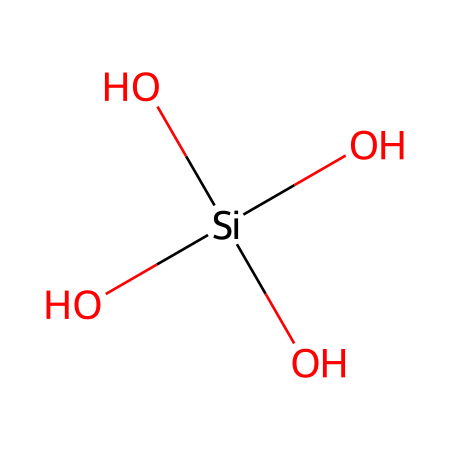How many oxygen atoms are in this chemical structure? The chemical structure contains four oxygen atoms, which can be identified from the visual representation where 'O' is shown four times.
Answer: four What is the central atom in this molecule? The central atom is silicon, which can be determined as 'Si' is present in the structure and is surrounded by oxygen atoms.
Answer: silicon How many hydroxyl groups are present in the structure? There are four hydroxyl groups (–OH) in this chemical structure. Each 'O' bonded to an 'H' signifies a hydroxyl group, and since there are four 'OH' groups, the answer is four.
Answer: four What type of bonding is predominantly present in this organosilicon compound? The predominant type of bonding in this molecule is covalent, as the silicon and oxygen atoms share electrons, a characteristic of organosilicon compounds.
Answer: covalent Is this compound likely to be hydrophilic or hydrophobic? The presence of multiple hydroxyl groups indicates that the compound is likely to be hydrophilic due to the ability of these groups to form hydrogen bonds with water.
Answer: hydrophilic What is the molecular formula for this chemical based on its structure? By counting the atoms in the chemical structure, the molecular formula is determined to be Si(OH)4, representing one silicon atom and four hydroxyl groups.
Answer: Si(OH)4 